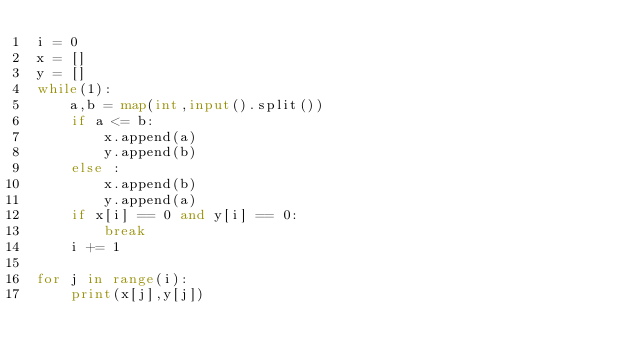Convert code to text. <code><loc_0><loc_0><loc_500><loc_500><_Python_>i = 0
x = []
y = []
while(1):
    a,b = map(int,input().split())
    if a <= b:
        x.append(a)
        y.append(b)
    else :
        x.append(b)
        y.append(a)
    if x[i] == 0 and y[i] == 0:
        break
    i += 1

for j in range(i):
    print(x[j],y[j])

</code> 